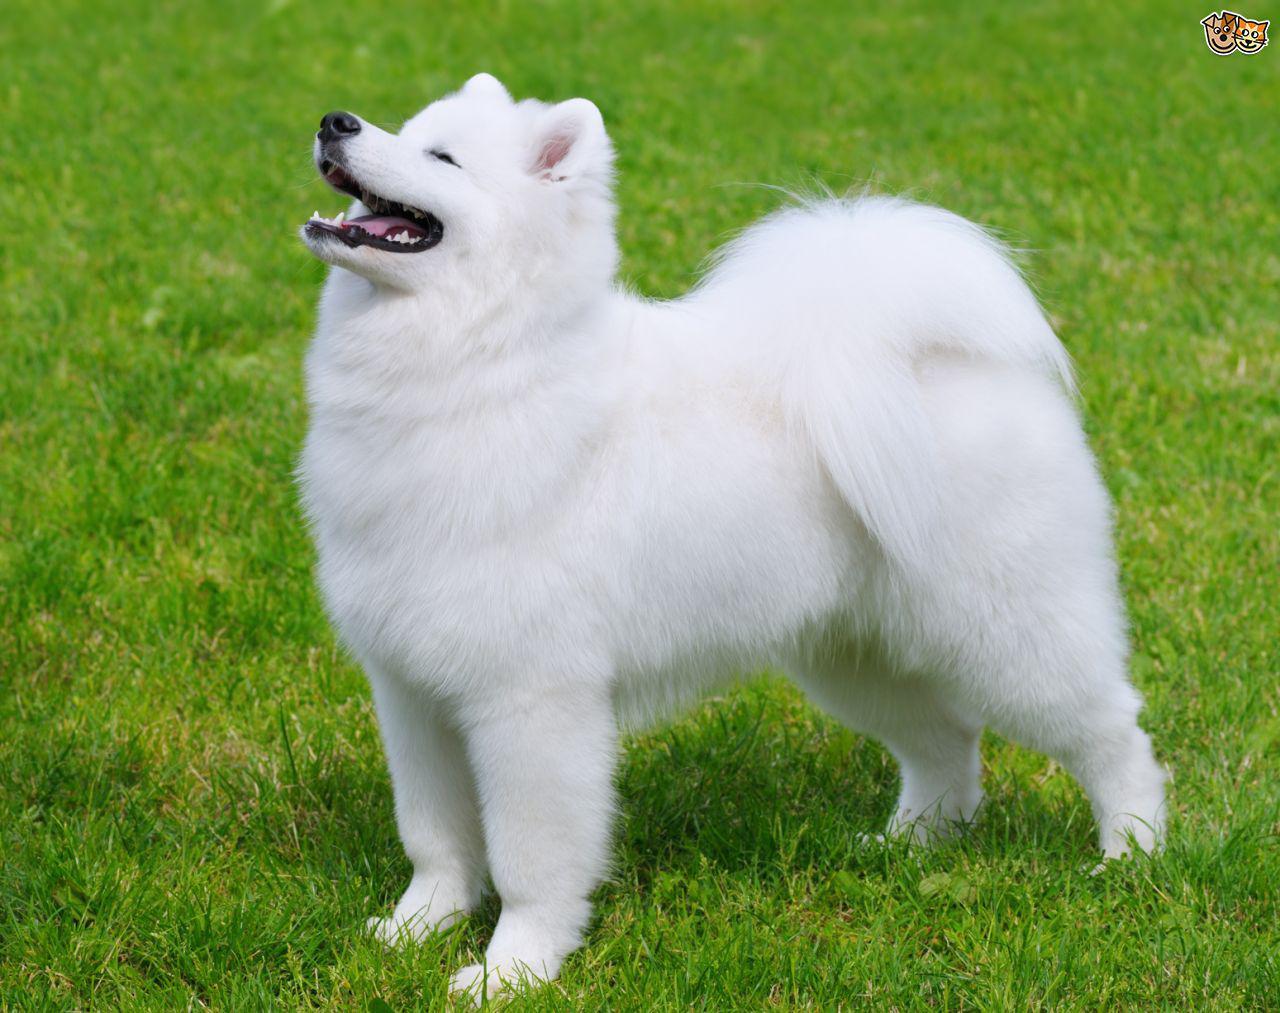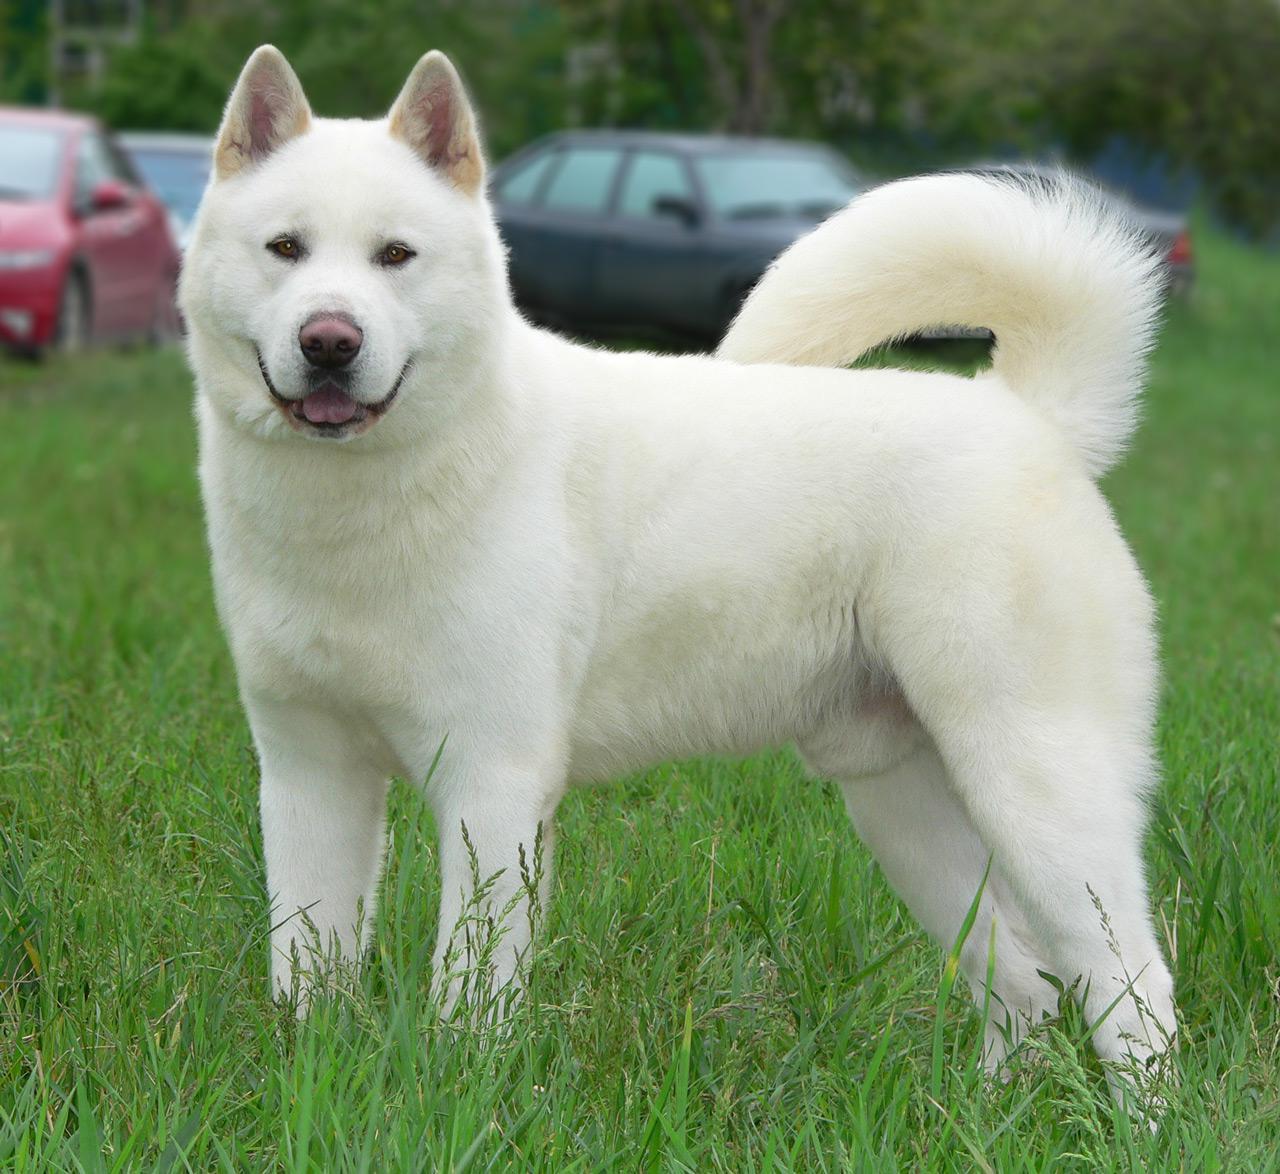The first image is the image on the left, the second image is the image on the right. Analyze the images presented: Is the assertion "One image features one or more white dogs reclining on grass." valid? Answer yes or no. No. 